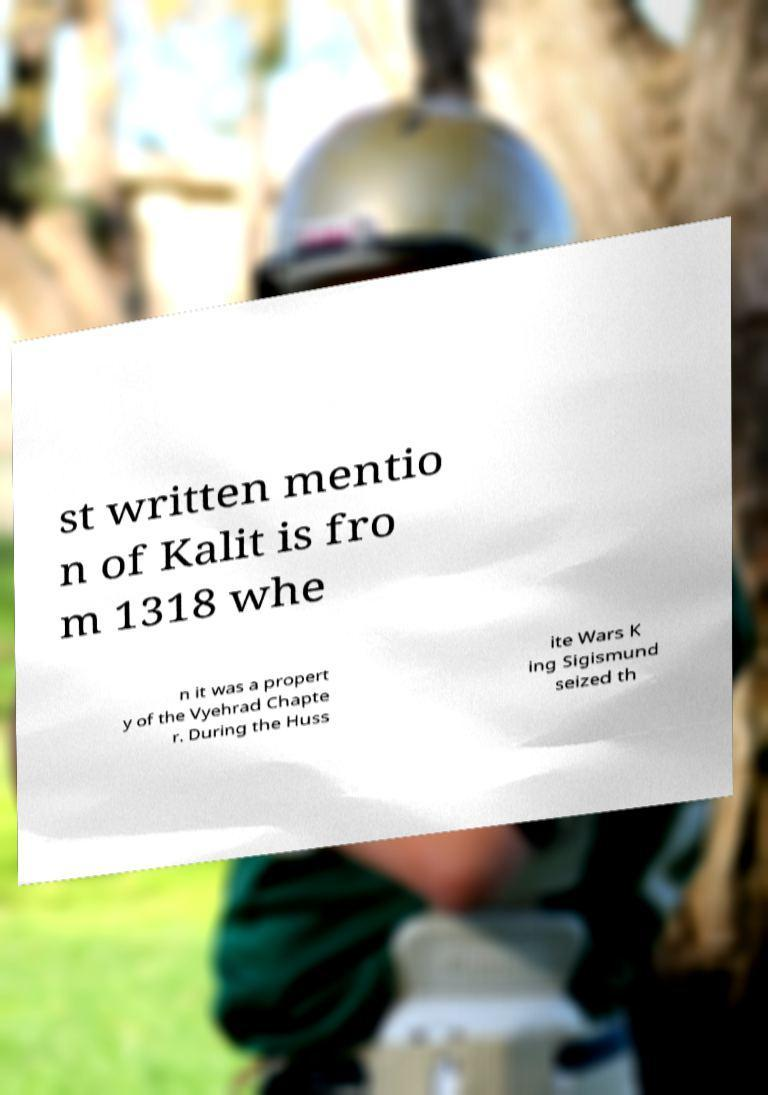What messages or text are displayed in this image? I need them in a readable, typed format. st written mentio n of Kalit is fro m 1318 whe n it was a propert y of the Vyehrad Chapte r. During the Huss ite Wars K ing Sigismund seized th 